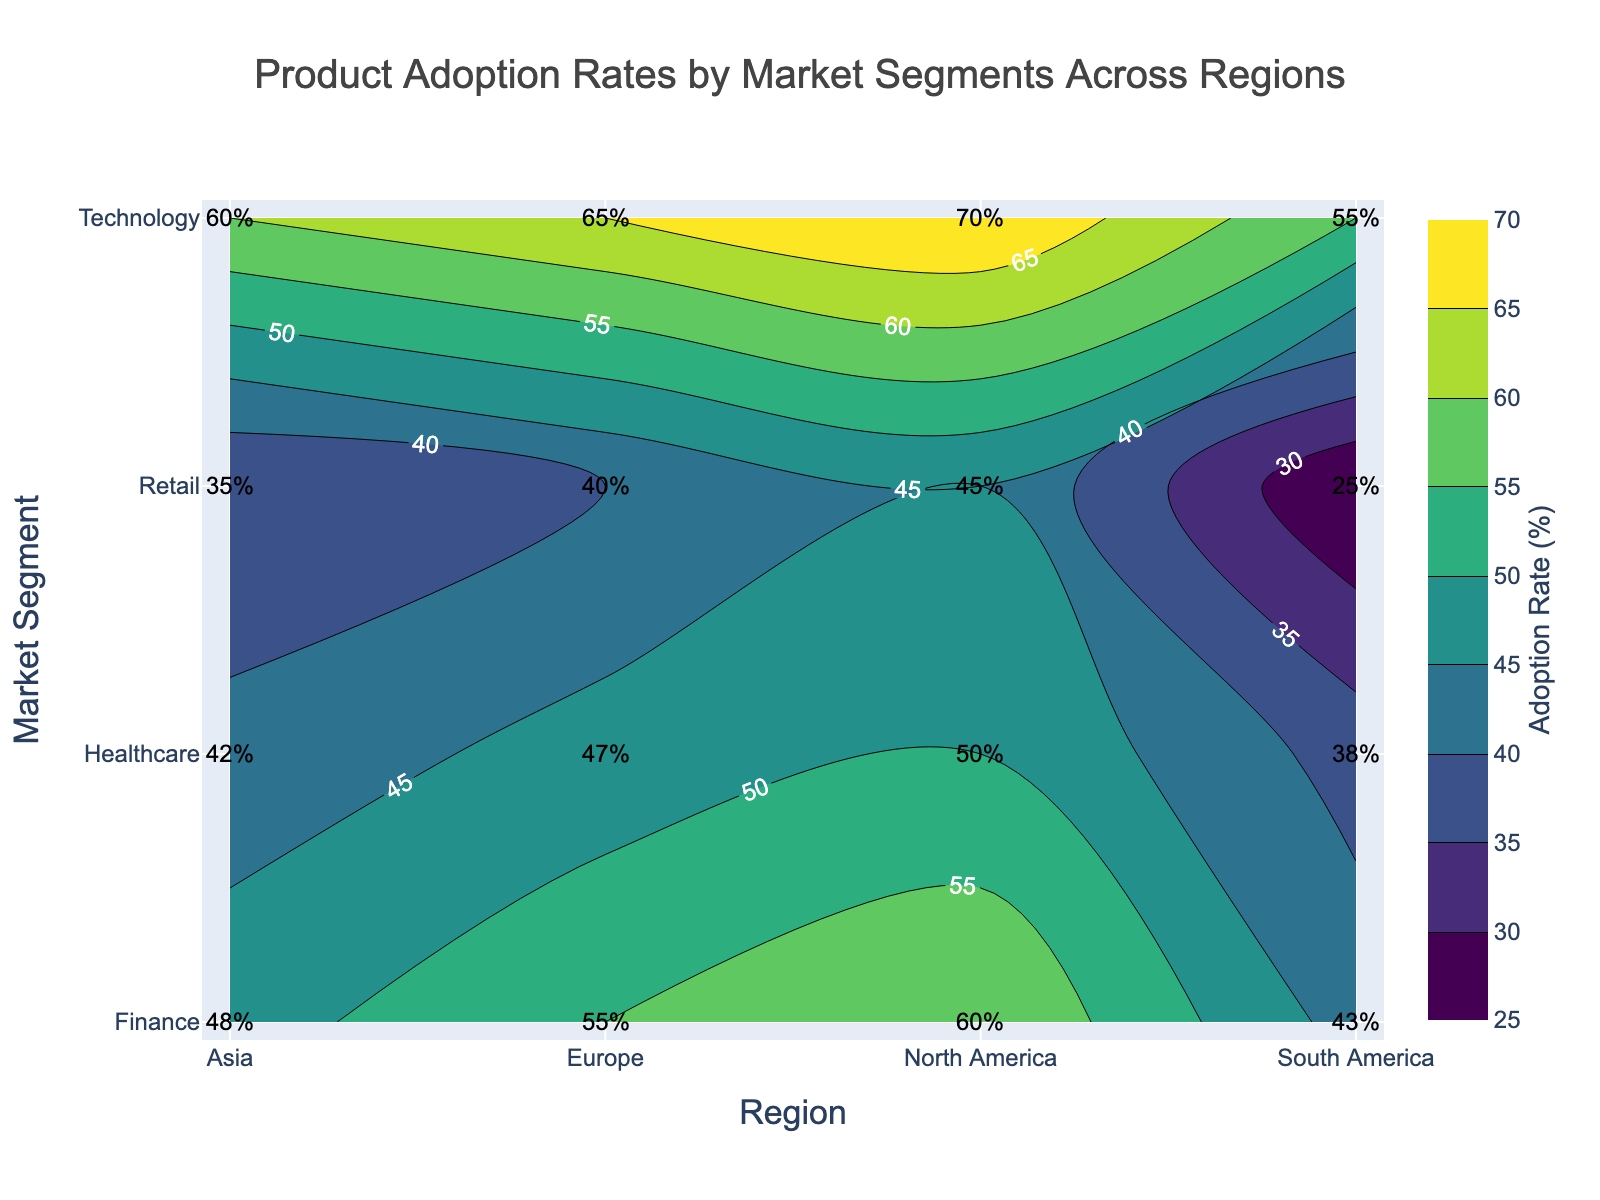what is the title of the figure? The title is usually located at the top center of the figure. It provides an overview of what the figure represents.
Answer: Product Adoption Rates by Market Segments Across Regions which market segment has the highest adoption rate in North America? The highest adoption rate for North America is indicated by the contour plot in the North America column for each market segment row. The highest value is found in the Technology segment.
Answer: Technology what are the adoption rates for the Healthcare segment in Europe and Asia? For the Healthcare segment, the adoption rates for Europe and Asia can be directly read from the labeled values on the plot. In Europe, it's 47%, and in Asia, it's 42%.
Answer: 47% in Europe, 42% in Asia what is the average adoption rate for the Finance segment across all regions? To find the average, you sum all the adoption rates for the Finance segment across all regions and then divide by the number of regions. (60+55+48+43)/4 = 206/4 = 51.5
Answer: 51.5% which region has the lowest adoption rate for the Retail segment? Compare the labeled adoption rates for the Retail segment across all regions: 45 in North America, 40 in Europe, 35 in Asia, and 25 in South America. The lowest rate is in South America.
Answer: South America is the adoption rate for Technology in Asia higher than the adoption rate for Retail in North America? Compare the adoption rates of Technology in Asia (60%) and Retail in North America (45%) by looking at the respective labeled values. 60% is higher than 45%.
Answer: Yes how does the adoption rate in South America vary across different market segments? The adoption rates in South America across market segments are labeled as follows: Retail (25%), Healthcare (38%), Finance (43%), Technology (55%). These values help understand the variation.
Answer: 25% to 55% which market segment shows the most considerable variation in adoption rates across the regions? To determine this, examine the range of adoption rates for each market segment across the regions and identify the one with the most significant difference. Technology ranges from 55% to 70%, showing the most variation (70-55=15).
Answer: Technology what is the sum of adoption rates for the Retail and Healthcare segments in North America? Add the adoption rates of Retail and Healthcare segments for North America. Retail is 45% and Healthcare is 50%. 45 + 50 = 95%
Answer: 95% is the adoption rate trend for Finance segment increasing or decreasing from North America to South America? Look at the labeled adoption rates for the Finance segment across the regions in the order: North America (60%), Europe (55%), Asia (48%), South America (43%). The trend is decreasing as the rates decline.
Answer: Decreasing 